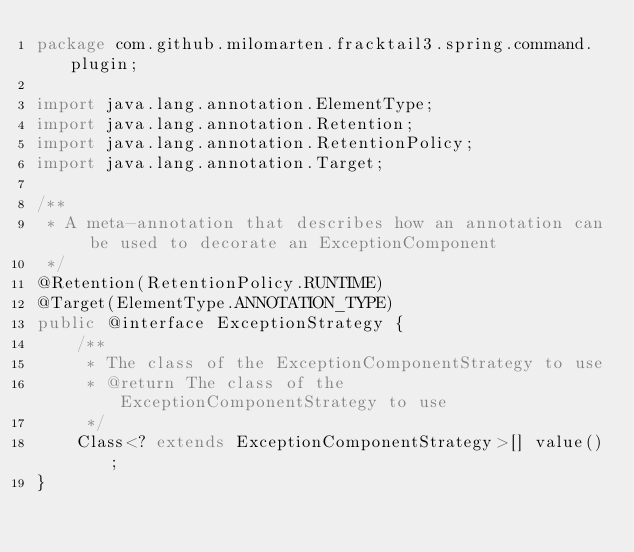Convert code to text. <code><loc_0><loc_0><loc_500><loc_500><_Java_>package com.github.milomarten.fracktail3.spring.command.plugin;

import java.lang.annotation.ElementType;
import java.lang.annotation.Retention;
import java.lang.annotation.RetentionPolicy;
import java.lang.annotation.Target;

/**
 * A meta-annotation that describes how an annotation can be used to decorate an ExceptionComponent
 */
@Retention(RetentionPolicy.RUNTIME)
@Target(ElementType.ANNOTATION_TYPE)
public @interface ExceptionStrategy {
    /**
     * The class of the ExceptionComponentStrategy to use
     * @return The class of the ExceptionComponentStrategy to use
     */
    Class<? extends ExceptionComponentStrategy>[] value();
}
</code> 